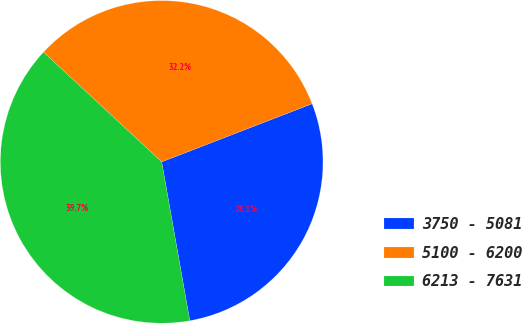<chart> <loc_0><loc_0><loc_500><loc_500><pie_chart><fcel>3750 - 5081<fcel>5100 - 6200<fcel>6213 - 7631<nl><fcel>28.08%<fcel>32.22%<fcel>39.7%<nl></chart> 